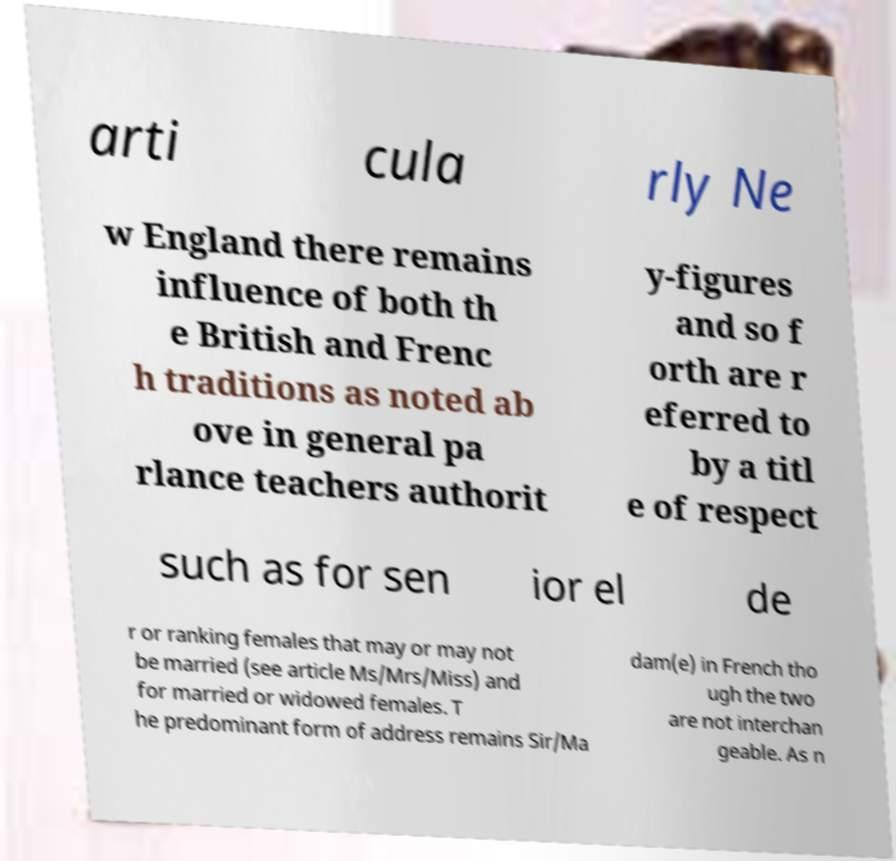Please identify and transcribe the text found in this image. arti cula rly Ne w England there remains influence of both th e British and Frenc h traditions as noted ab ove in general pa rlance teachers authorit y-figures and so f orth are r eferred to by a titl e of respect such as for sen ior el de r or ranking females that may or may not be married (see article Ms/Mrs/Miss) and for married or widowed females. T he predominant form of address remains Sir/Ma dam(e) in French tho ugh the two are not interchan geable. As n 